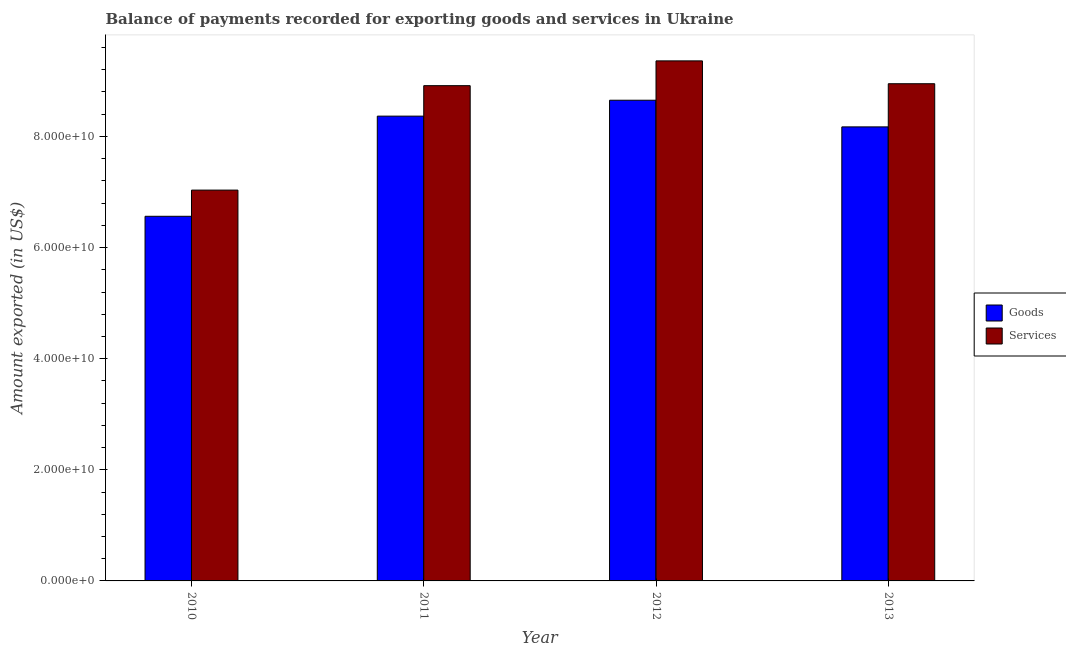Are the number of bars on each tick of the X-axis equal?
Provide a succinct answer. Yes. In how many cases, is the number of bars for a given year not equal to the number of legend labels?
Give a very brief answer. 0. What is the amount of services exported in 2012?
Make the answer very short. 9.36e+1. Across all years, what is the maximum amount of services exported?
Make the answer very short. 9.36e+1. Across all years, what is the minimum amount of services exported?
Provide a succinct answer. 7.03e+1. In which year was the amount of goods exported maximum?
Your answer should be compact. 2012. In which year was the amount of services exported minimum?
Provide a succinct answer. 2010. What is the total amount of services exported in the graph?
Offer a very short reply. 3.43e+11. What is the difference between the amount of services exported in 2010 and that in 2012?
Offer a terse response. -2.33e+1. What is the difference between the amount of services exported in 2011 and the amount of goods exported in 2010?
Ensure brevity in your answer.  1.88e+1. What is the average amount of services exported per year?
Ensure brevity in your answer.  8.56e+1. In the year 2010, what is the difference between the amount of goods exported and amount of services exported?
Give a very brief answer. 0. What is the ratio of the amount of goods exported in 2010 to that in 2013?
Offer a very short reply. 0.8. Is the amount of services exported in 2010 less than that in 2012?
Ensure brevity in your answer.  Yes. Is the difference between the amount of services exported in 2010 and 2011 greater than the difference between the amount of goods exported in 2010 and 2011?
Your answer should be very brief. No. What is the difference between the highest and the second highest amount of services exported?
Make the answer very short. 4.11e+09. What is the difference between the highest and the lowest amount of services exported?
Make the answer very short. 2.33e+1. Is the sum of the amount of services exported in 2011 and 2012 greater than the maximum amount of goods exported across all years?
Keep it short and to the point. Yes. What does the 1st bar from the left in 2010 represents?
Your response must be concise. Goods. What does the 1st bar from the right in 2010 represents?
Your answer should be compact. Services. How many bars are there?
Provide a succinct answer. 8. Are all the bars in the graph horizontal?
Provide a succinct answer. No. Are the values on the major ticks of Y-axis written in scientific E-notation?
Provide a short and direct response. Yes. Does the graph contain any zero values?
Your answer should be compact. No. Does the graph contain grids?
Give a very brief answer. No. How are the legend labels stacked?
Provide a succinct answer. Vertical. What is the title of the graph?
Keep it short and to the point. Balance of payments recorded for exporting goods and services in Ukraine. Does "Non-residents" appear as one of the legend labels in the graph?
Your answer should be compact. No. What is the label or title of the Y-axis?
Ensure brevity in your answer.  Amount exported (in US$). What is the Amount exported (in US$) in Goods in 2010?
Your response must be concise. 6.56e+1. What is the Amount exported (in US$) of Services in 2010?
Your answer should be compact. 7.03e+1. What is the Amount exported (in US$) in Goods in 2011?
Your answer should be compact. 8.37e+1. What is the Amount exported (in US$) of Services in 2011?
Provide a succinct answer. 8.91e+1. What is the Amount exported (in US$) in Goods in 2012?
Ensure brevity in your answer.  8.65e+1. What is the Amount exported (in US$) of Services in 2012?
Ensure brevity in your answer.  9.36e+1. What is the Amount exported (in US$) of Goods in 2013?
Ensure brevity in your answer.  8.17e+1. What is the Amount exported (in US$) of Services in 2013?
Offer a very short reply. 8.95e+1. Across all years, what is the maximum Amount exported (in US$) of Goods?
Ensure brevity in your answer.  8.65e+1. Across all years, what is the maximum Amount exported (in US$) in Services?
Make the answer very short. 9.36e+1. Across all years, what is the minimum Amount exported (in US$) of Goods?
Provide a succinct answer. 6.56e+1. Across all years, what is the minimum Amount exported (in US$) in Services?
Make the answer very short. 7.03e+1. What is the total Amount exported (in US$) in Goods in the graph?
Offer a very short reply. 3.18e+11. What is the total Amount exported (in US$) in Services in the graph?
Keep it short and to the point. 3.43e+11. What is the difference between the Amount exported (in US$) of Goods in 2010 and that in 2011?
Your answer should be compact. -1.80e+1. What is the difference between the Amount exported (in US$) in Services in 2010 and that in 2011?
Your response must be concise. -1.88e+1. What is the difference between the Amount exported (in US$) in Goods in 2010 and that in 2012?
Make the answer very short. -2.09e+1. What is the difference between the Amount exported (in US$) in Services in 2010 and that in 2012?
Ensure brevity in your answer.  -2.33e+1. What is the difference between the Amount exported (in US$) in Goods in 2010 and that in 2013?
Give a very brief answer. -1.61e+1. What is the difference between the Amount exported (in US$) of Services in 2010 and that in 2013?
Keep it short and to the point. -1.91e+1. What is the difference between the Amount exported (in US$) in Goods in 2011 and that in 2012?
Keep it short and to the point. -2.86e+09. What is the difference between the Amount exported (in US$) of Services in 2011 and that in 2012?
Keep it short and to the point. -4.46e+09. What is the difference between the Amount exported (in US$) of Goods in 2011 and that in 2013?
Make the answer very short. 1.93e+09. What is the difference between the Amount exported (in US$) of Services in 2011 and that in 2013?
Keep it short and to the point. -3.49e+08. What is the difference between the Amount exported (in US$) in Goods in 2012 and that in 2013?
Provide a succinct answer. 4.80e+09. What is the difference between the Amount exported (in US$) of Services in 2012 and that in 2013?
Offer a terse response. 4.11e+09. What is the difference between the Amount exported (in US$) in Goods in 2010 and the Amount exported (in US$) in Services in 2011?
Provide a succinct answer. -2.35e+1. What is the difference between the Amount exported (in US$) in Goods in 2010 and the Amount exported (in US$) in Services in 2012?
Give a very brief answer. -2.80e+1. What is the difference between the Amount exported (in US$) in Goods in 2010 and the Amount exported (in US$) in Services in 2013?
Offer a very short reply. -2.39e+1. What is the difference between the Amount exported (in US$) of Goods in 2011 and the Amount exported (in US$) of Services in 2012?
Provide a succinct answer. -9.95e+09. What is the difference between the Amount exported (in US$) in Goods in 2011 and the Amount exported (in US$) in Services in 2013?
Keep it short and to the point. -5.83e+09. What is the difference between the Amount exported (in US$) in Goods in 2012 and the Amount exported (in US$) in Services in 2013?
Offer a terse response. -2.97e+09. What is the average Amount exported (in US$) of Goods per year?
Make the answer very short. 7.94e+1. What is the average Amount exported (in US$) in Services per year?
Ensure brevity in your answer.  8.56e+1. In the year 2010, what is the difference between the Amount exported (in US$) of Goods and Amount exported (in US$) of Services?
Your answer should be compact. -4.72e+09. In the year 2011, what is the difference between the Amount exported (in US$) in Goods and Amount exported (in US$) in Services?
Your response must be concise. -5.48e+09. In the year 2012, what is the difference between the Amount exported (in US$) in Goods and Amount exported (in US$) in Services?
Your response must be concise. -7.08e+09. In the year 2013, what is the difference between the Amount exported (in US$) of Goods and Amount exported (in US$) of Services?
Make the answer very short. -7.77e+09. What is the ratio of the Amount exported (in US$) of Goods in 2010 to that in 2011?
Provide a short and direct response. 0.78. What is the ratio of the Amount exported (in US$) of Services in 2010 to that in 2011?
Give a very brief answer. 0.79. What is the ratio of the Amount exported (in US$) of Goods in 2010 to that in 2012?
Your answer should be compact. 0.76. What is the ratio of the Amount exported (in US$) in Services in 2010 to that in 2012?
Provide a succinct answer. 0.75. What is the ratio of the Amount exported (in US$) of Goods in 2010 to that in 2013?
Your answer should be very brief. 0.8. What is the ratio of the Amount exported (in US$) of Services in 2010 to that in 2013?
Provide a short and direct response. 0.79. What is the ratio of the Amount exported (in US$) in Goods in 2011 to that in 2012?
Provide a succinct answer. 0.97. What is the ratio of the Amount exported (in US$) in Services in 2011 to that in 2012?
Give a very brief answer. 0.95. What is the ratio of the Amount exported (in US$) of Goods in 2011 to that in 2013?
Keep it short and to the point. 1.02. What is the ratio of the Amount exported (in US$) of Services in 2011 to that in 2013?
Give a very brief answer. 1. What is the ratio of the Amount exported (in US$) of Goods in 2012 to that in 2013?
Make the answer very short. 1.06. What is the ratio of the Amount exported (in US$) of Services in 2012 to that in 2013?
Your answer should be compact. 1.05. What is the difference between the highest and the second highest Amount exported (in US$) in Goods?
Your response must be concise. 2.86e+09. What is the difference between the highest and the second highest Amount exported (in US$) in Services?
Make the answer very short. 4.11e+09. What is the difference between the highest and the lowest Amount exported (in US$) in Goods?
Make the answer very short. 2.09e+1. What is the difference between the highest and the lowest Amount exported (in US$) of Services?
Keep it short and to the point. 2.33e+1. 